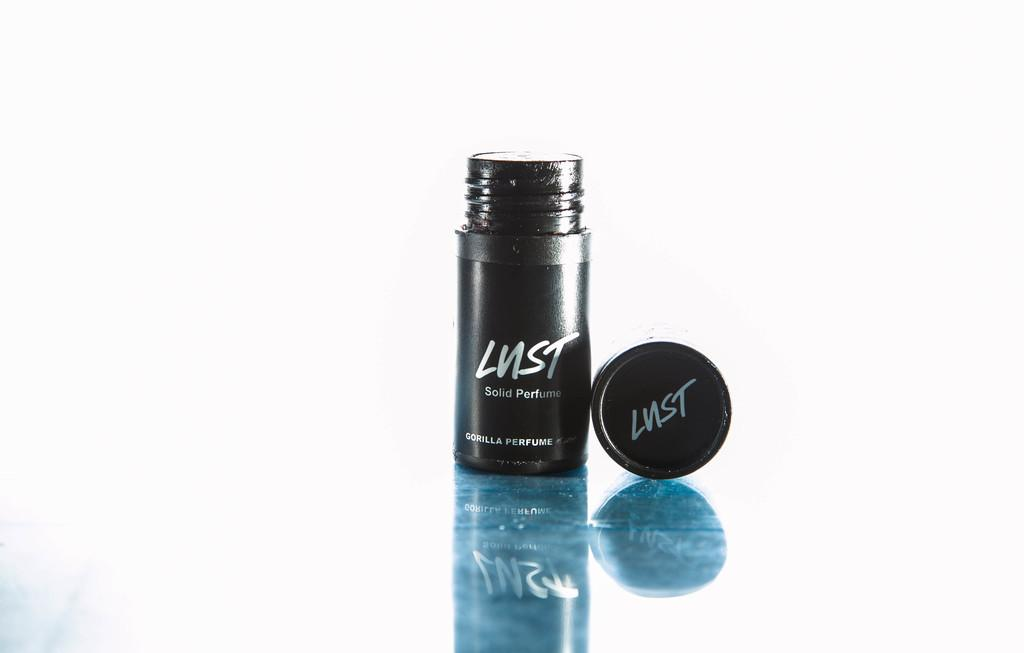<image>
Summarize the visual content of the image. Black bottle with the word Lust on it. 